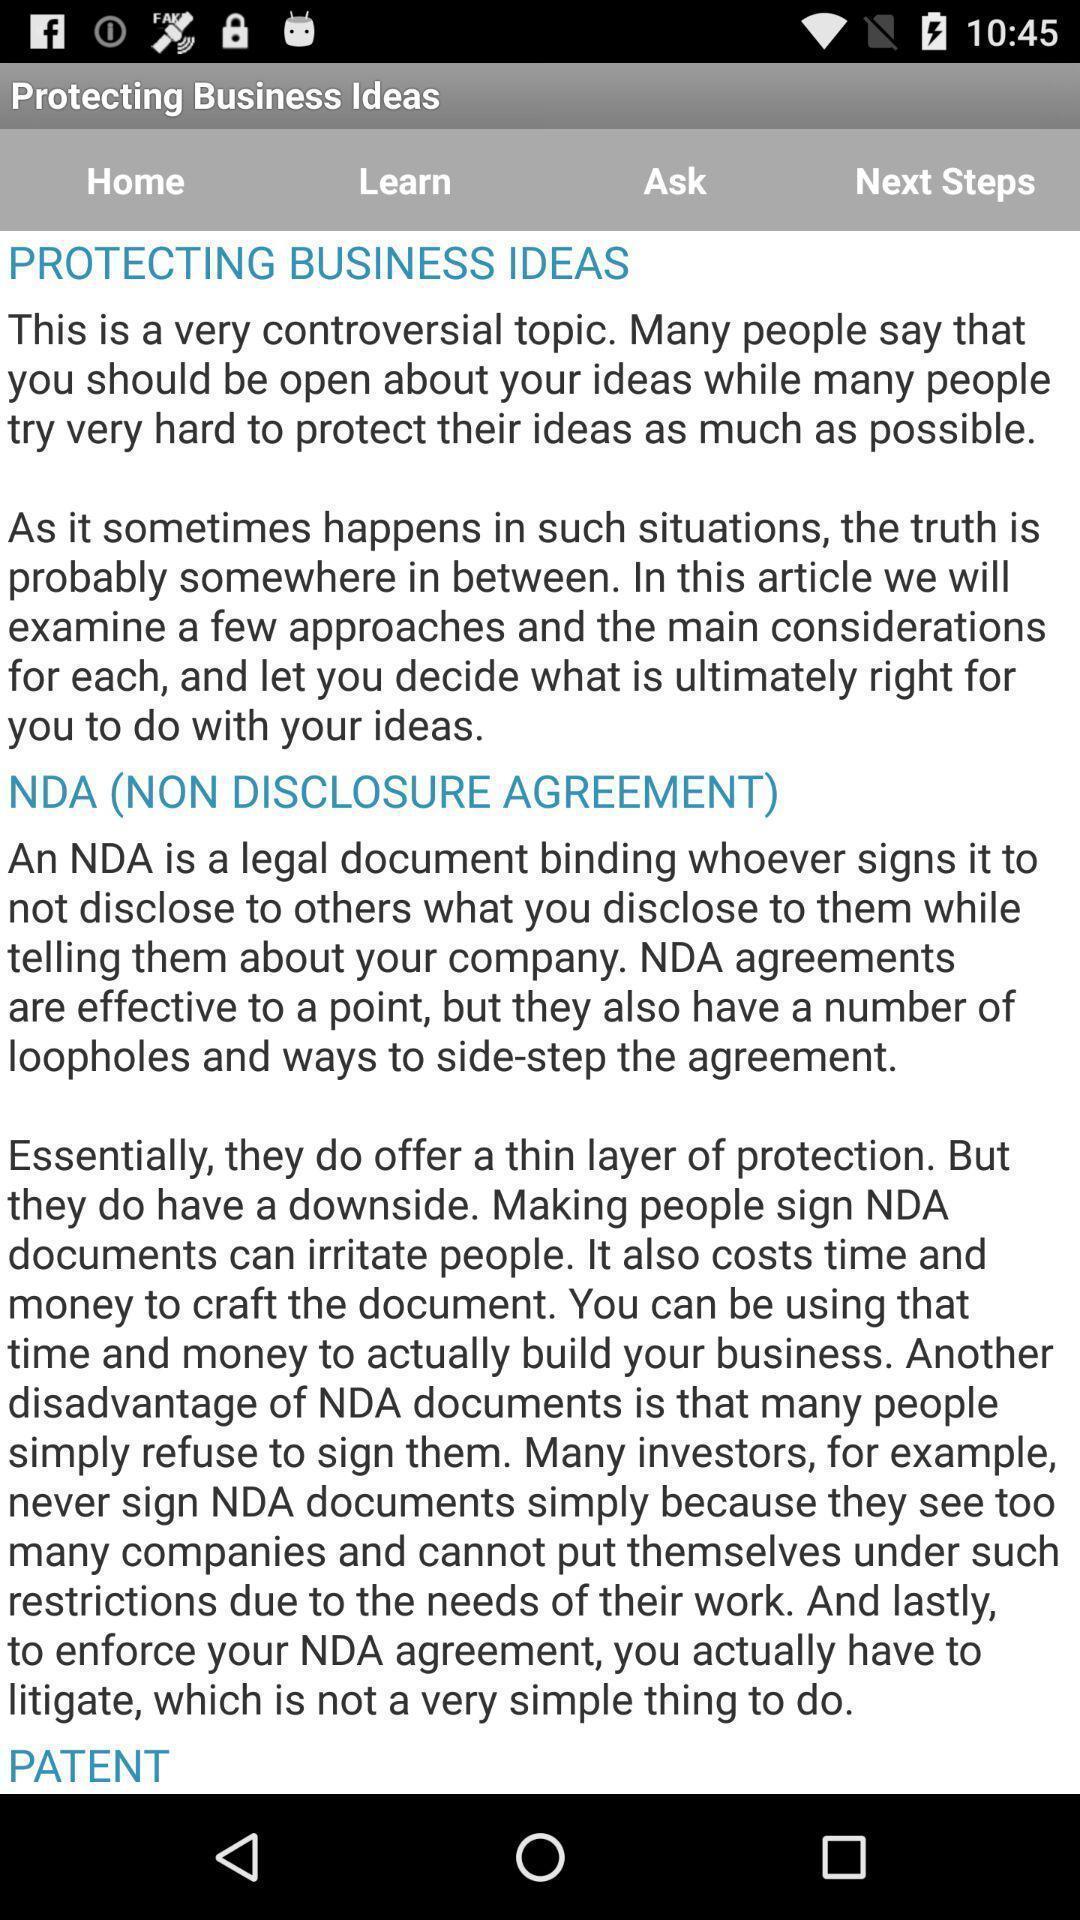Summarize the information in this screenshot. Page displaying information about application. 